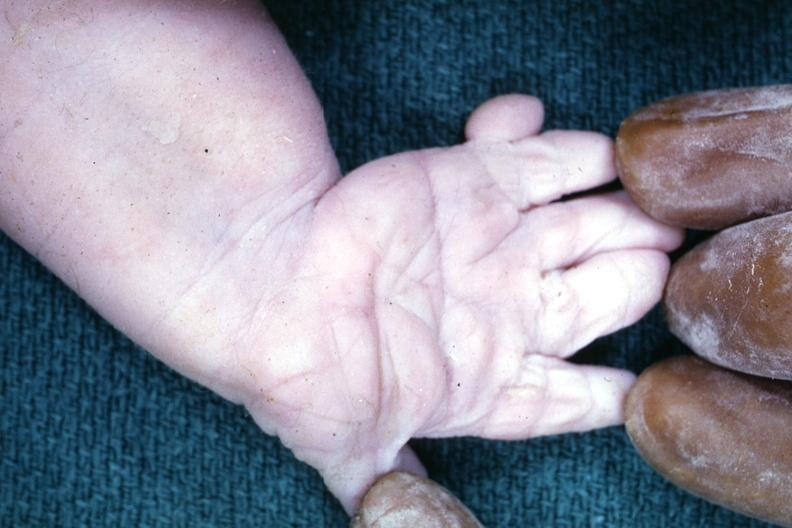does malignant adenoma show simian crease?
Answer the question using a single word or phrase. No 